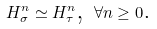Convert formula to latex. <formula><loc_0><loc_0><loc_500><loc_500>H _ { \sigma } ^ { n } \simeq H _ { \tau } ^ { n } \text {, } \forall n \geq 0 \text {.}</formula> 